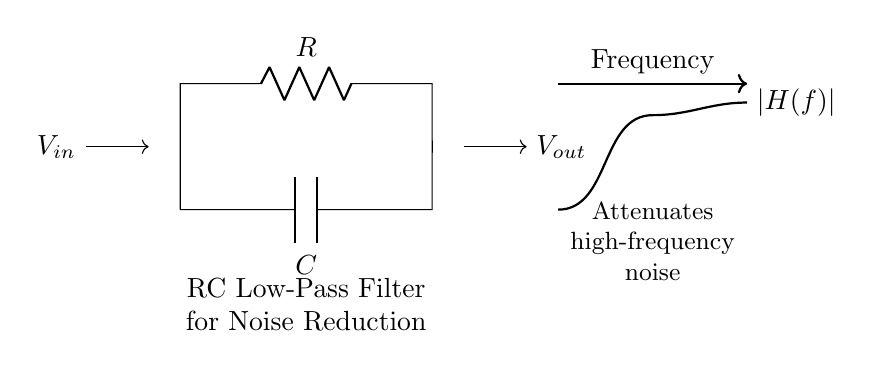What are the components in this circuit? The components in the circuit include a resistor labeled "R" and a capacitor labeled "C." These are essential components for creating an RC filter.
Answer: Resistor and Capacitor What is the purpose of this RC filter? The purpose of this RC filter is to attenuate high-frequency noise, which is indicated in the circuit diagram. This is commonly used in audio systems to improve sound quality.
Answer: Noise reduction What type of filter does this circuit represent? This circuit represents a low-pass filter, as it allows low-frequency signals to pass while reducing high-frequency noise, as stated in the description below the circuit.
Answer: Low-pass filter What is the input label of the circuit? The input label for the circuit is "Vin," which indicates where the input voltage is applied to the circuit for processing.
Answer: Vin What does the output of this circuit signify? The output of this circuit, labeled "Vout," signifies the voltage after the filter has processed the input signal, reflecting the degree of noise reduction applied.
Answer: Vout What effect does this filter have on frequency response? The filter attenuates high frequencies, as depicted in the diagram and the description provided, meaning that higher frequencies are reduced more than lower ones.
Answer: Attenuates high frequencies What is the relationship between the resistor and capacitor in this circuit? The resistor and capacitor in this RC filter work together to create a time constant that defines the cutoff frequency of the filter, influencing how quickly the circuit responds to changes in input signals.
Answer: Creates a time constant 